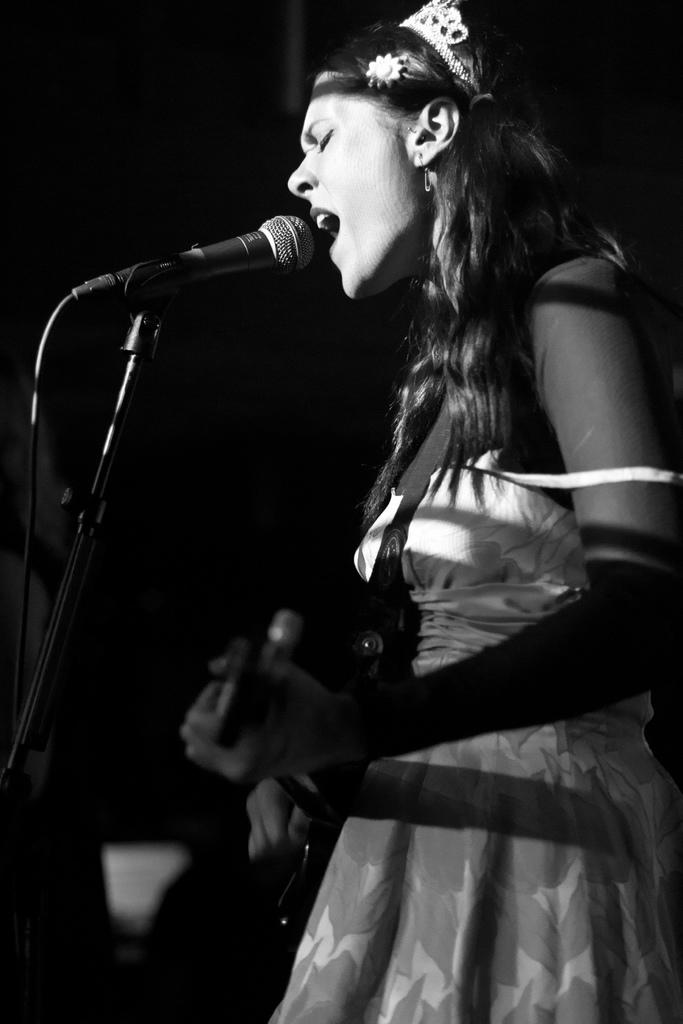What is the main subject of the black and white image? There is a black and white image of a woman. What is the woman doing in the image? The woman is standing and singing a song. What is she holding in her hand? She is holding a microphone. How is the microphone positioned in the image? The microphone is on a stand. What can be observed about the background of the image? The background is dark. What type of hole can be seen in the image? There is no hole present in the image. Can you tell me how many uncles are visible in the image? There are no uncles present in the image; it features a woman singing with a microphone. 